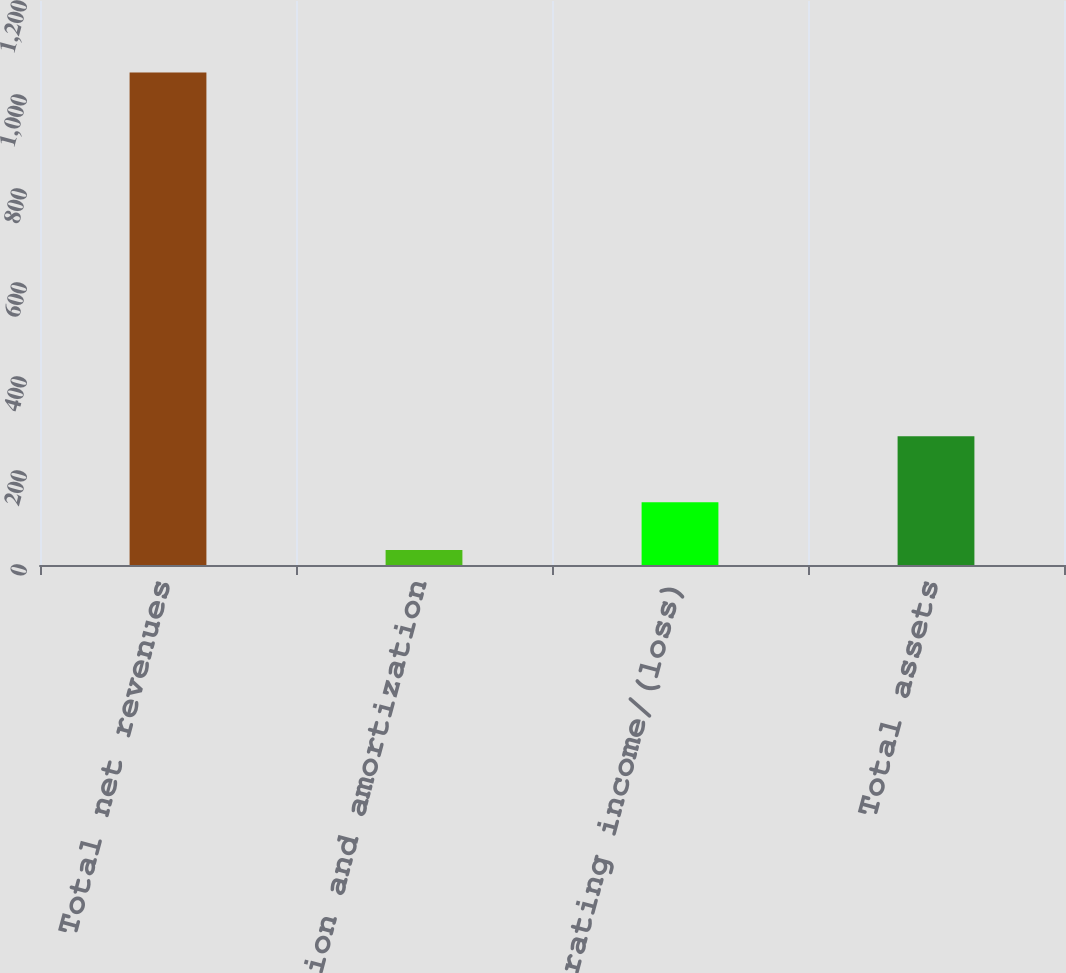Convert chart. <chart><loc_0><loc_0><loc_500><loc_500><bar_chart><fcel>Total net revenues<fcel>Depreciation and amortization<fcel>Operating income/(loss)<fcel>Total assets<nl><fcel>1048<fcel>31.7<fcel>133.33<fcel>273.8<nl></chart> 